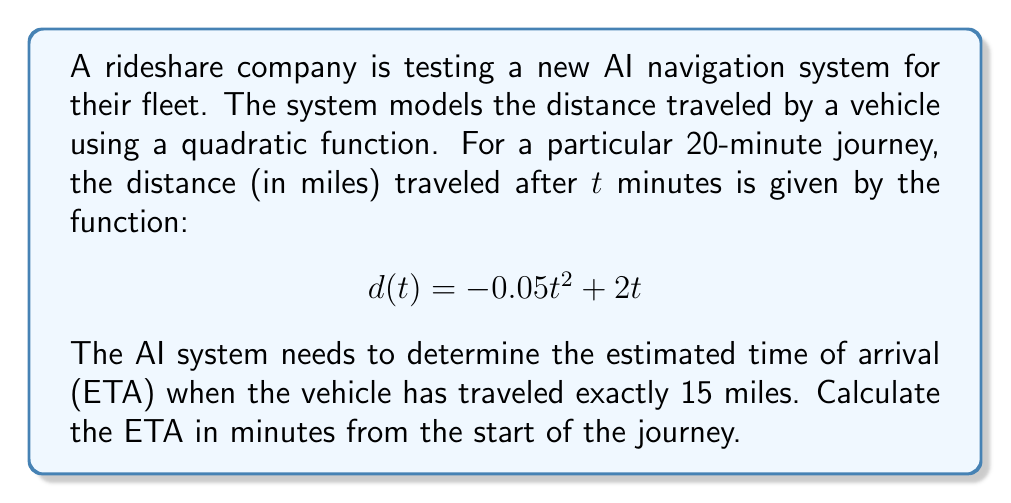Help me with this question. To solve this problem, we need to find the value of t when d(t) = 15 miles. This involves solving a quadratic equation.

1. Set up the equation:
   $$ 15 = -0.05t^2 + 2t $$

2. Rearrange the equation to standard form $(at^2 + bt + c = 0)$:
   $$ 0.05t^2 - 2t + 15 = 0 $$

3. Use the quadratic formula: $t = \frac{-b \pm \sqrt{b^2 - 4ac}}{2a}$
   Where $a = 0.05$, $b = -2$, and $c = 15$

4. Substitute these values into the quadratic formula:
   $$ t = \frac{2 \pm \sqrt{(-2)^2 - 4(0.05)(15)}}{2(0.05)} $$

5. Simplify:
   $$ t = \frac{2 \pm \sqrt{4 - 3}}{0.1} = \frac{2 \pm \sqrt{1}}{0.1} = \frac{2 \pm 1}{0.1} $$

6. This gives us two solutions:
   $$ t_1 = \frac{2 + 1}{0.1} = 30 \text{ minutes} $$
   $$ t_2 = \frac{2 - 1}{0.1} = 10 \text{ minutes} $$

7. Since we're asked for the ETA and the journey starts at t = 0, we choose the larger value, 30 minutes.

Therefore, the estimated time of arrival is 30 minutes from the start of the journey.
Answer: The estimated time of arrival (ETA) is 30 minutes from the start of the journey. 